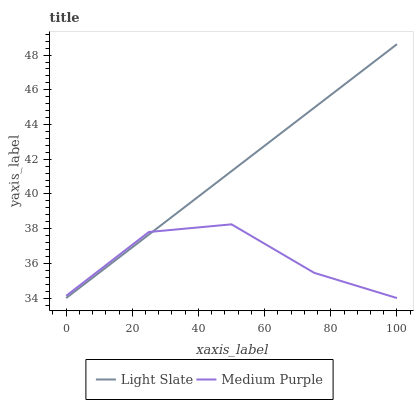Does Medium Purple have the minimum area under the curve?
Answer yes or no. Yes. Does Light Slate have the maximum area under the curve?
Answer yes or no. Yes. Does Medium Purple have the maximum area under the curve?
Answer yes or no. No. Is Light Slate the smoothest?
Answer yes or no. Yes. Is Medium Purple the roughest?
Answer yes or no. Yes. Is Medium Purple the smoothest?
Answer yes or no. No. Does Light Slate have the highest value?
Answer yes or no. Yes. Does Medium Purple have the highest value?
Answer yes or no. No. Does Medium Purple intersect Light Slate?
Answer yes or no. Yes. Is Medium Purple less than Light Slate?
Answer yes or no. No. Is Medium Purple greater than Light Slate?
Answer yes or no. No. 